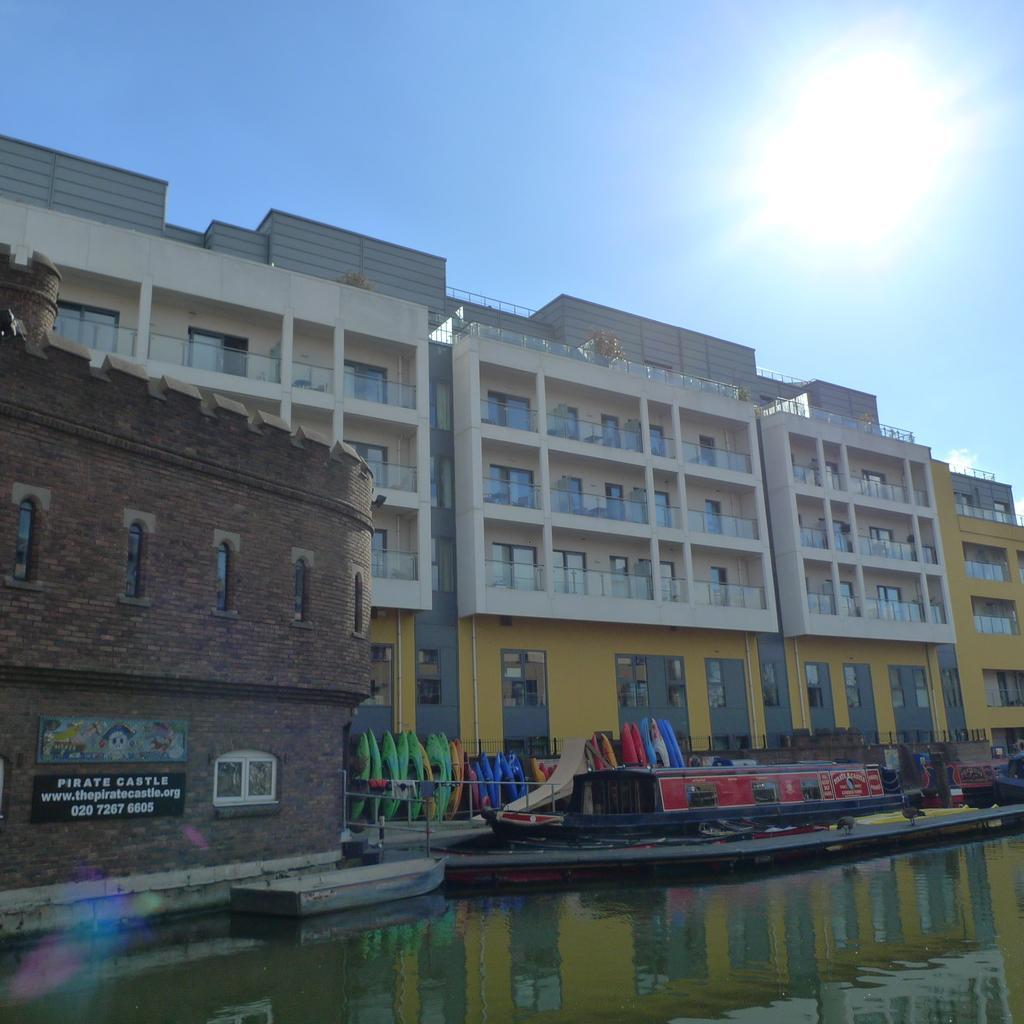What is the main structure in the picture? There is a huge building in the picture. What is located in front of the building? There is a lake in front of the building. What can be seen on the lake? There are boats on the lake. How many kittens are swimming in the lake in the image? There are no kittens present in the image; it features a lake with boats. What type of salt is being used to season the building in the image? There is no salt or seasoning mentioned in the image, as it features a building, a lake, and boats. 